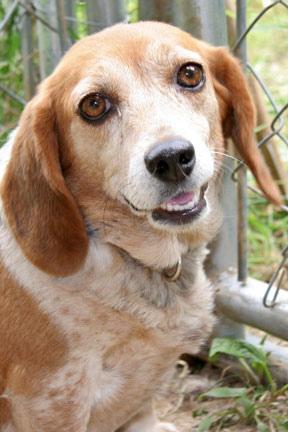How many dogs are there?
Give a very brief answer. 1. 